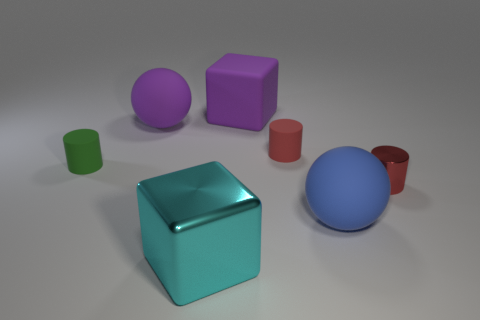What number of tiny blue metallic objects are there?
Make the answer very short. 0. What number of small objects are either red rubber cylinders or gray cylinders?
Ensure brevity in your answer.  1. There is a blue rubber object that is the same size as the cyan cube; what shape is it?
Provide a short and direct response. Sphere. Is there any other thing that has the same size as the metallic block?
Your answer should be compact. Yes. What is the material of the small red thing to the right of the red rubber object that is behind the tiny red shiny object?
Offer a terse response. Metal. Does the red metallic cylinder have the same size as the purple matte cube?
Provide a short and direct response. No. What number of objects are either objects behind the blue rubber sphere or small objects?
Provide a short and direct response. 5. What shape is the big matte thing behind the large ball behind the blue object?
Offer a very short reply. Cube. Is the size of the blue ball the same as the ball that is behind the green rubber cylinder?
Ensure brevity in your answer.  Yes. What material is the small cylinder on the left side of the small red matte thing?
Offer a very short reply. Rubber. 